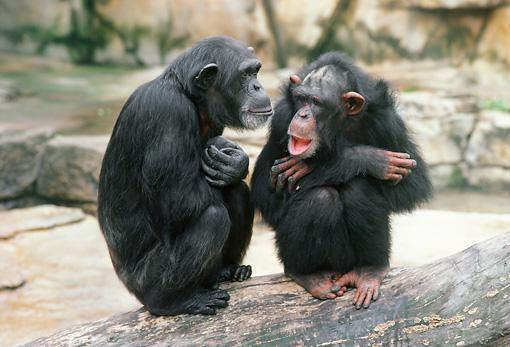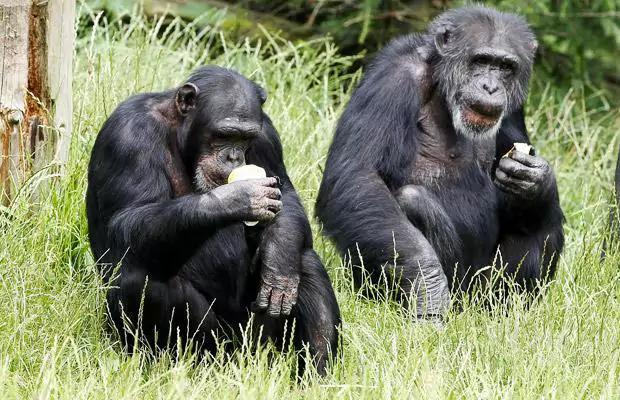The first image is the image on the left, the second image is the image on the right. Evaluate the accuracy of this statement regarding the images: "Two primates sit in a grassy area in the image on the right.". Is it true? Answer yes or no. Yes. The first image is the image on the left, the second image is the image on the right. Examine the images to the left and right. Is the description "An image shows a pair of squatting apes that each hold a food-type item in one hand." accurate? Answer yes or no. Yes. 